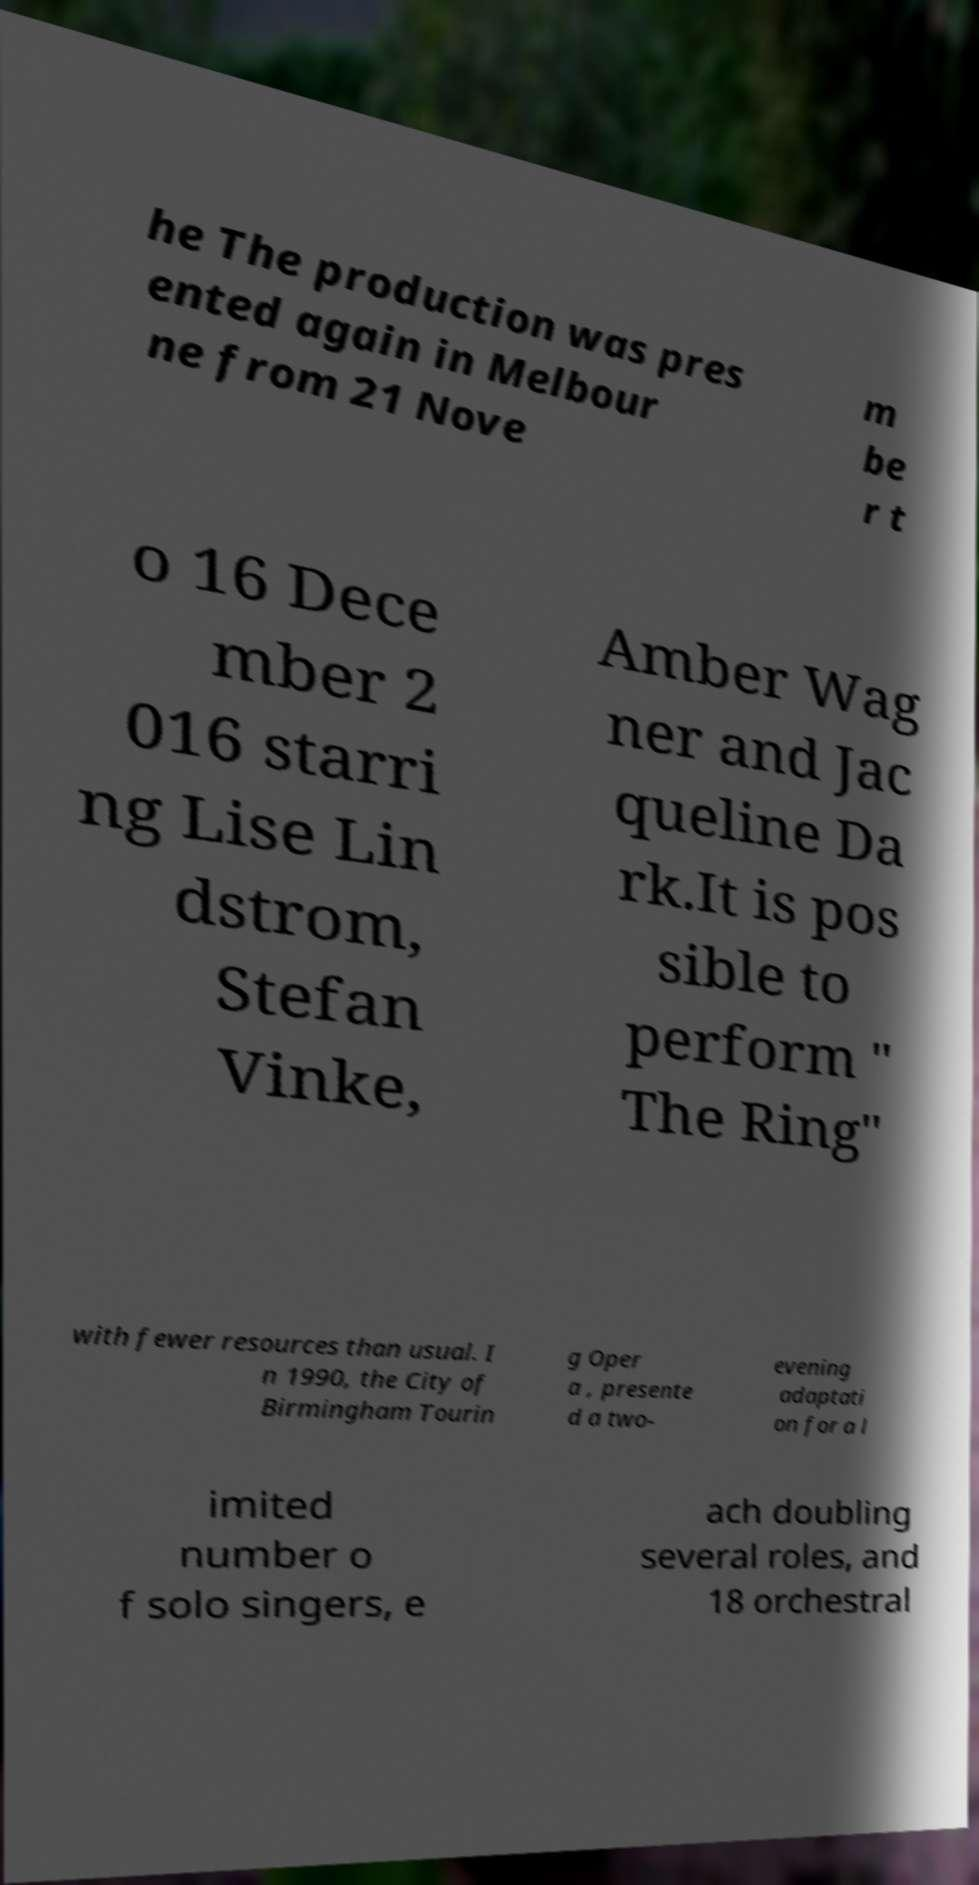Could you assist in decoding the text presented in this image and type it out clearly? he The production was pres ented again in Melbour ne from 21 Nove m be r t o 16 Dece mber 2 016 starri ng Lise Lin dstrom, Stefan Vinke, Amber Wag ner and Jac queline Da rk.It is pos sible to perform " The Ring" with fewer resources than usual. I n 1990, the City of Birmingham Tourin g Oper a , presente d a two- evening adaptati on for a l imited number o f solo singers, e ach doubling several roles, and 18 orchestral 